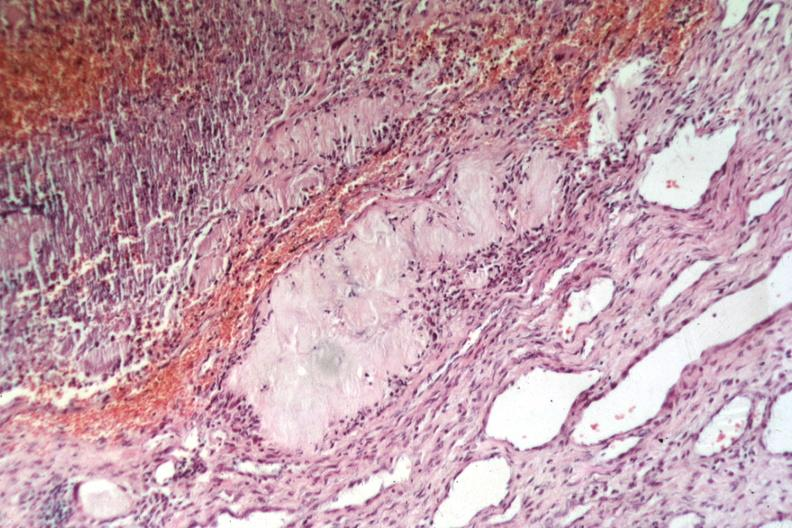s siamese twins present?
Answer the question using a single word or phrase. No 